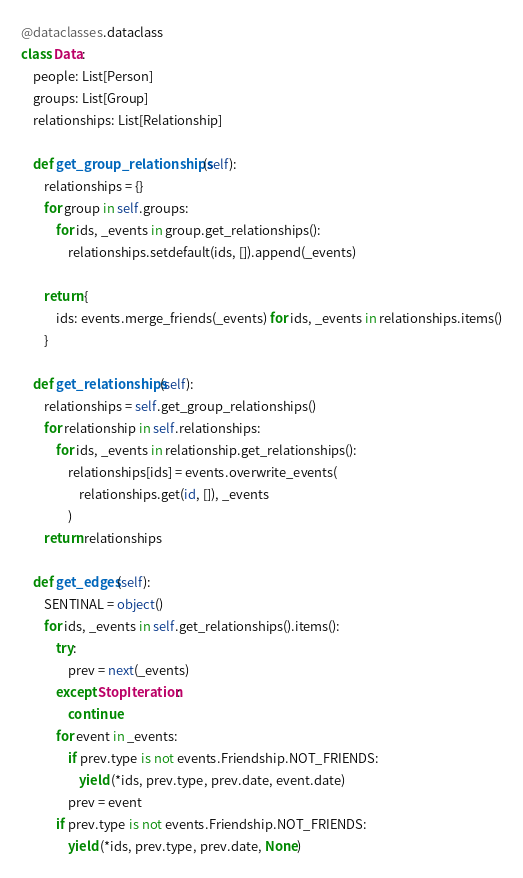Convert code to text. <code><loc_0><loc_0><loc_500><loc_500><_Python_>@dataclasses.dataclass
class Data:
    people: List[Person]
    groups: List[Group]
    relationships: List[Relationship]

    def get_group_relationships(self):
        relationships = {}
        for group in self.groups:
            for ids, _events in group.get_relationships():
                relationships.setdefault(ids, []).append(_events)

        return {
            ids: events.merge_friends(_events) for ids, _events in relationships.items()
        }

    def get_relationships(self):
        relationships = self.get_group_relationships()
        for relationship in self.relationships:
            for ids, _events in relationship.get_relationships():
                relationships[ids] = events.overwrite_events(
                    relationships.get(id, []), _events
                )
        return relationships

    def get_edges(self):
        SENTINAL = object()
        for ids, _events in self.get_relationships().items():
            try:
                prev = next(_events)
            except StopIteration:
                continue
            for event in _events:
                if prev.type is not events.Friendship.NOT_FRIENDS:
                    yield (*ids, prev.type, prev.date, event.date)
                prev = event
            if prev.type is not events.Friendship.NOT_FRIENDS:
                yield (*ids, prev.type, prev.date, None)
</code> 